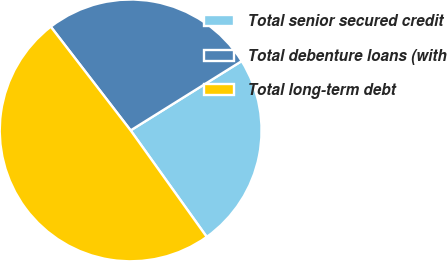Convert chart. <chart><loc_0><loc_0><loc_500><loc_500><pie_chart><fcel>Total senior secured credit<fcel>Total debenture loans (with<fcel>Total long-term debt<nl><fcel>24.01%<fcel>26.56%<fcel>49.43%<nl></chart> 